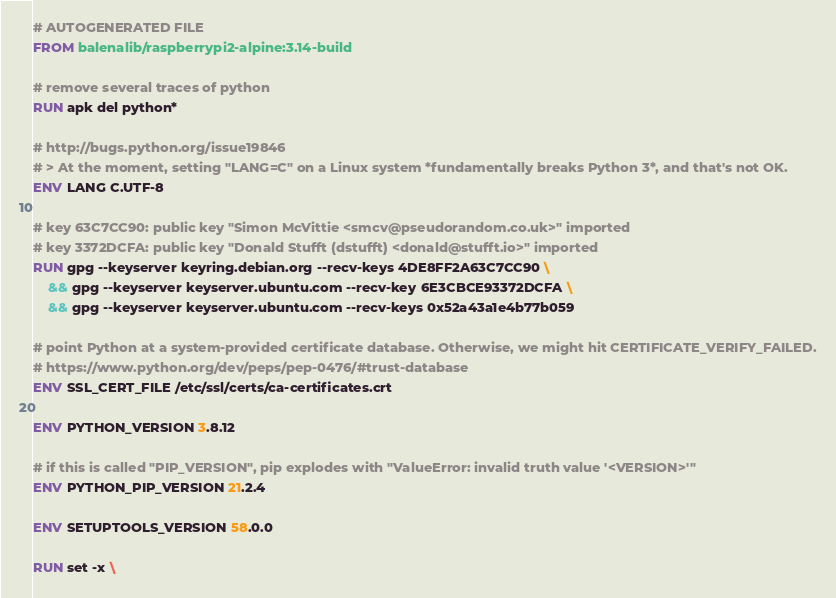Convert code to text. <code><loc_0><loc_0><loc_500><loc_500><_Dockerfile_># AUTOGENERATED FILE
FROM balenalib/raspberrypi2-alpine:3.14-build

# remove several traces of python
RUN apk del python*

# http://bugs.python.org/issue19846
# > At the moment, setting "LANG=C" on a Linux system *fundamentally breaks Python 3*, and that's not OK.
ENV LANG C.UTF-8

# key 63C7CC90: public key "Simon McVittie <smcv@pseudorandom.co.uk>" imported
# key 3372DCFA: public key "Donald Stufft (dstufft) <donald@stufft.io>" imported
RUN gpg --keyserver keyring.debian.org --recv-keys 4DE8FF2A63C7CC90 \
	&& gpg --keyserver keyserver.ubuntu.com --recv-key 6E3CBCE93372DCFA \
	&& gpg --keyserver keyserver.ubuntu.com --recv-keys 0x52a43a1e4b77b059

# point Python at a system-provided certificate database. Otherwise, we might hit CERTIFICATE_VERIFY_FAILED.
# https://www.python.org/dev/peps/pep-0476/#trust-database
ENV SSL_CERT_FILE /etc/ssl/certs/ca-certificates.crt

ENV PYTHON_VERSION 3.8.12

# if this is called "PIP_VERSION", pip explodes with "ValueError: invalid truth value '<VERSION>'"
ENV PYTHON_PIP_VERSION 21.2.4

ENV SETUPTOOLS_VERSION 58.0.0

RUN set -x \</code> 